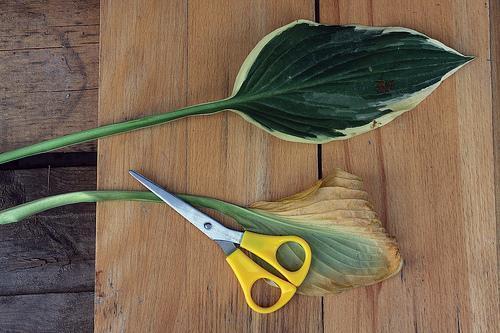How many leaves are shown?
Give a very brief answer. 2. 